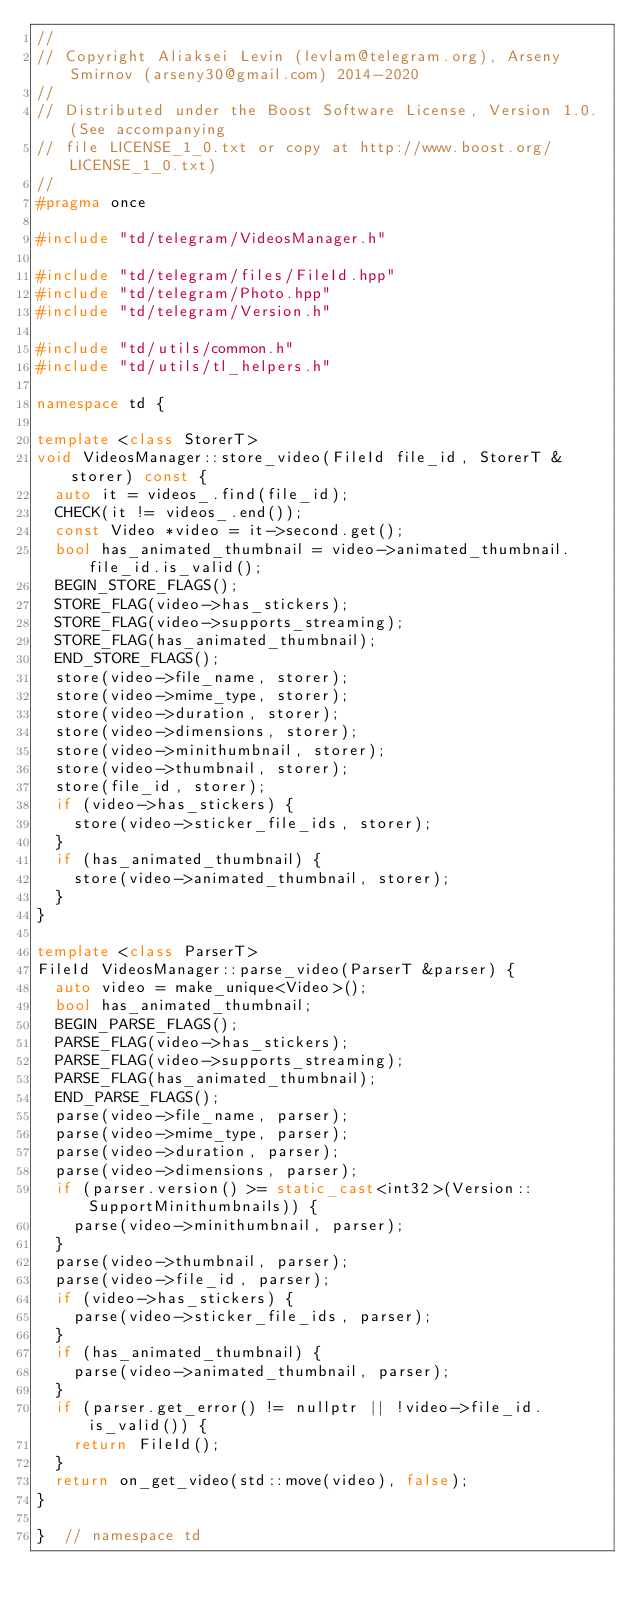Convert code to text. <code><loc_0><loc_0><loc_500><loc_500><_C++_>//
// Copyright Aliaksei Levin (levlam@telegram.org), Arseny Smirnov (arseny30@gmail.com) 2014-2020
//
// Distributed under the Boost Software License, Version 1.0. (See accompanying
// file LICENSE_1_0.txt or copy at http://www.boost.org/LICENSE_1_0.txt)
//
#pragma once

#include "td/telegram/VideosManager.h"

#include "td/telegram/files/FileId.hpp"
#include "td/telegram/Photo.hpp"
#include "td/telegram/Version.h"

#include "td/utils/common.h"
#include "td/utils/tl_helpers.h"

namespace td {

template <class StorerT>
void VideosManager::store_video(FileId file_id, StorerT &storer) const {
  auto it = videos_.find(file_id);
  CHECK(it != videos_.end());
  const Video *video = it->second.get();
  bool has_animated_thumbnail = video->animated_thumbnail.file_id.is_valid();
  BEGIN_STORE_FLAGS();
  STORE_FLAG(video->has_stickers);
  STORE_FLAG(video->supports_streaming);
  STORE_FLAG(has_animated_thumbnail);
  END_STORE_FLAGS();
  store(video->file_name, storer);
  store(video->mime_type, storer);
  store(video->duration, storer);
  store(video->dimensions, storer);
  store(video->minithumbnail, storer);
  store(video->thumbnail, storer);
  store(file_id, storer);
  if (video->has_stickers) {
    store(video->sticker_file_ids, storer);
  }
  if (has_animated_thumbnail) {
    store(video->animated_thumbnail, storer);
  }
}

template <class ParserT>
FileId VideosManager::parse_video(ParserT &parser) {
  auto video = make_unique<Video>();
  bool has_animated_thumbnail;
  BEGIN_PARSE_FLAGS();
  PARSE_FLAG(video->has_stickers);
  PARSE_FLAG(video->supports_streaming);
  PARSE_FLAG(has_animated_thumbnail);
  END_PARSE_FLAGS();
  parse(video->file_name, parser);
  parse(video->mime_type, parser);
  parse(video->duration, parser);
  parse(video->dimensions, parser);
  if (parser.version() >= static_cast<int32>(Version::SupportMinithumbnails)) {
    parse(video->minithumbnail, parser);
  }
  parse(video->thumbnail, parser);
  parse(video->file_id, parser);
  if (video->has_stickers) {
    parse(video->sticker_file_ids, parser);
  }
  if (has_animated_thumbnail) {
    parse(video->animated_thumbnail, parser);
  }
  if (parser.get_error() != nullptr || !video->file_id.is_valid()) {
    return FileId();
  }
  return on_get_video(std::move(video), false);
}

}  // namespace td
</code> 